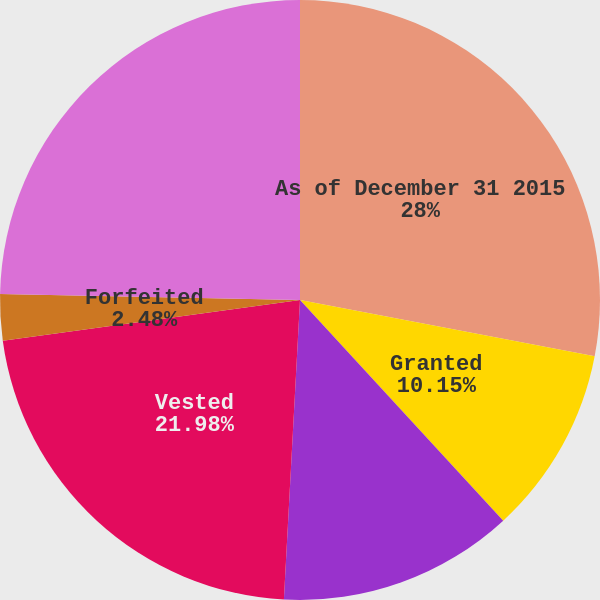Convert chart. <chart><loc_0><loc_0><loc_500><loc_500><pie_chart><fcel>As of December 31 2015<fcel>Granted<fcel>Additional performance-based<fcel>Vested<fcel>Forfeited<fcel>As of December 31 2016<nl><fcel>28.01%<fcel>10.15%<fcel>12.7%<fcel>21.98%<fcel>2.48%<fcel>24.69%<nl></chart> 